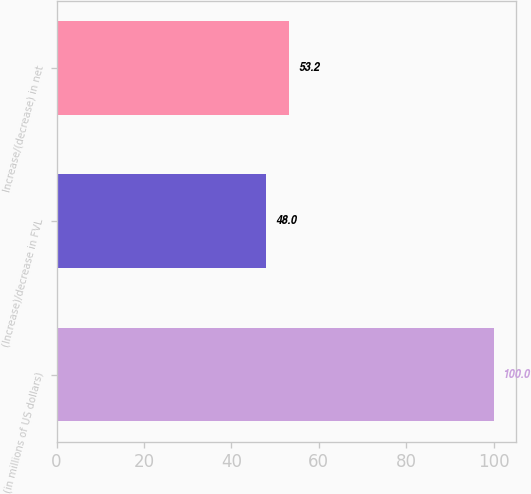Convert chart to OTSL. <chart><loc_0><loc_0><loc_500><loc_500><bar_chart><fcel>(in millions of US dollars)<fcel>(Increase)/decrease in FVL<fcel>Increase/(decrease) in net<nl><fcel>100<fcel>48<fcel>53.2<nl></chart> 